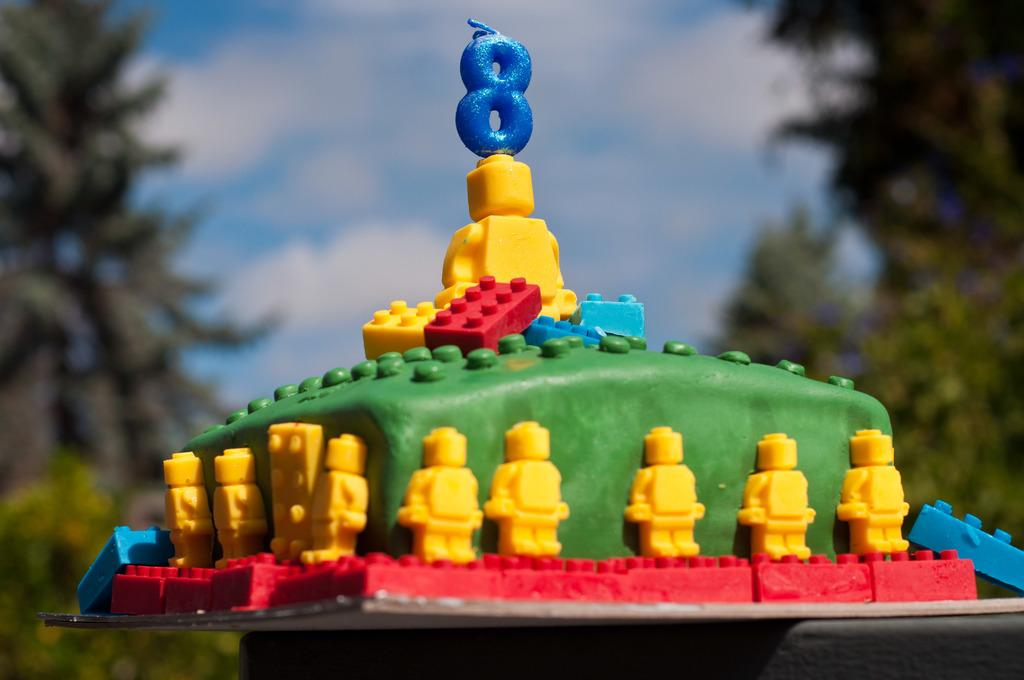What is the main subject in the center of the image? There is a cake in the center of the image. What can be seen in the background of the image? There are trees and the sky visible in the background of the image. How many chickens are present in the image? There are no chickens present in the image. 